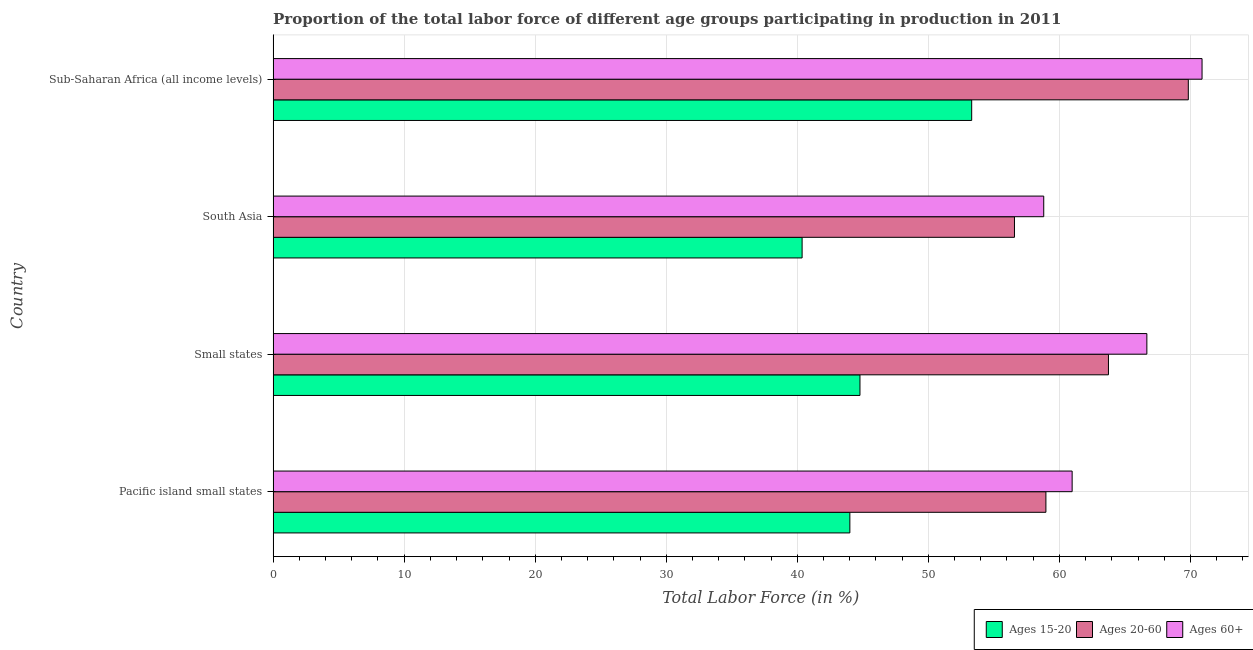Are the number of bars on each tick of the Y-axis equal?
Give a very brief answer. Yes. How many bars are there on the 3rd tick from the top?
Ensure brevity in your answer.  3. How many bars are there on the 4th tick from the bottom?
Offer a very short reply. 3. What is the label of the 3rd group of bars from the top?
Offer a very short reply. Small states. What is the percentage of labor force within the age group 20-60 in Sub-Saharan Africa (all income levels)?
Offer a very short reply. 69.84. Across all countries, what is the maximum percentage of labor force above age 60?
Your response must be concise. 70.89. Across all countries, what is the minimum percentage of labor force within the age group 15-20?
Your answer should be very brief. 40.37. In which country was the percentage of labor force above age 60 maximum?
Ensure brevity in your answer.  Sub-Saharan Africa (all income levels). In which country was the percentage of labor force within the age group 15-20 minimum?
Give a very brief answer. South Asia. What is the total percentage of labor force within the age group 20-60 in the graph?
Your response must be concise. 249.13. What is the difference between the percentage of labor force within the age group 20-60 in Small states and that in Sub-Saharan Africa (all income levels)?
Your answer should be very brief. -6.09. What is the difference between the percentage of labor force within the age group 20-60 in South Asia and the percentage of labor force within the age group 15-20 in Sub-Saharan Africa (all income levels)?
Give a very brief answer. 3.27. What is the average percentage of labor force above age 60 per country?
Give a very brief answer. 64.34. What is the difference between the percentage of labor force within the age group 20-60 and percentage of labor force above age 60 in Small states?
Give a very brief answer. -2.93. What is the ratio of the percentage of labor force within the age group 20-60 in Pacific island small states to that in Small states?
Provide a short and direct response. 0.93. What is the difference between the highest and the second highest percentage of labor force within the age group 15-20?
Give a very brief answer. 8.53. What is the difference between the highest and the lowest percentage of labor force above age 60?
Provide a succinct answer. 12.08. What does the 2nd bar from the top in Small states represents?
Your response must be concise. Ages 20-60. What does the 1st bar from the bottom in Pacific island small states represents?
Your answer should be very brief. Ages 15-20. Are all the bars in the graph horizontal?
Offer a very short reply. Yes. What is the difference between two consecutive major ticks on the X-axis?
Provide a short and direct response. 10. Are the values on the major ticks of X-axis written in scientific E-notation?
Keep it short and to the point. No. Does the graph contain any zero values?
Keep it short and to the point. No. Does the graph contain grids?
Your answer should be compact. Yes. What is the title of the graph?
Provide a succinct answer. Proportion of the total labor force of different age groups participating in production in 2011. Does "Ages 15-20" appear as one of the legend labels in the graph?
Offer a terse response. Yes. What is the Total Labor Force (in %) of Ages 15-20 in Pacific island small states?
Give a very brief answer. 44.01. What is the Total Labor Force (in %) of Ages 20-60 in Pacific island small states?
Offer a very short reply. 58.97. What is the Total Labor Force (in %) in Ages 60+ in Pacific island small states?
Offer a very short reply. 60.97. What is the Total Labor Force (in %) in Ages 15-20 in Small states?
Provide a succinct answer. 44.78. What is the Total Labor Force (in %) of Ages 20-60 in Small states?
Give a very brief answer. 63.75. What is the Total Labor Force (in %) of Ages 60+ in Small states?
Make the answer very short. 66.68. What is the Total Labor Force (in %) of Ages 15-20 in South Asia?
Make the answer very short. 40.37. What is the Total Labor Force (in %) in Ages 20-60 in South Asia?
Your answer should be very brief. 56.57. What is the Total Labor Force (in %) of Ages 60+ in South Asia?
Your response must be concise. 58.81. What is the Total Labor Force (in %) of Ages 15-20 in Sub-Saharan Africa (all income levels)?
Your answer should be compact. 53.31. What is the Total Labor Force (in %) of Ages 20-60 in Sub-Saharan Africa (all income levels)?
Offer a terse response. 69.84. What is the Total Labor Force (in %) in Ages 60+ in Sub-Saharan Africa (all income levels)?
Offer a very short reply. 70.89. Across all countries, what is the maximum Total Labor Force (in %) in Ages 15-20?
Keep it short and to the point. 53.31. Across all countries, what is the maximum Total Labor Force (in %) in Ages 20-60?
Make the answer very short. 69.84. Across all countries, what is the maximum Total Labor Force (in %) in Ages 60+?
Ensure brevity in your answer.  70.89. Across all countries, what is the minimum Total Labor Force (in %) in Ages 15-20?
Your answer should be very brief. 40.37. Across all countries, what is the minimum Total Labor Force (in %) of Ages 20-60?
Offer a terse response. 56.57. Across all countries, what is the minimum Total Labor Force (in %) of Ages 60+?
Provide a short and direct response. 58.81. What is the total Total Labor Force (in %) of Ages 15-20 in the graph?
Make the answer very short. 182.47. What is the total Total Labor Force (in %) in Ages 20-60 in the graph?
Give a very brief answer. 249.13. What is the total Total Labor Force (in %) of Ages 60+ in the graph?
Offer a terse response. 257.35. What is the difference between the Total Labor Force (in %) in Ages 15-20 in Pacific island small states and that in Small states?
Offer a very short reply. -0.77. What is the difference between the Total Labor Force (in %) of Ages 20-60 in Pacific island small states and that in Small states?
Keep it short and to the point. -4.77. What is the difference between the Total Labor Force (in %) of Ages 60+ in Pacific island small states and that in Small states?
Make the answer very short. -5.7. What is the difference between the Total Labor Force (in %) of Ages 15-20 in Pacific island small states and that in South Asia?
Ensure brevity in your answer.  3.64. What is the difference between the Total Labor Force (in %) of Ages 20-60 in Pacific island small states and that in South Asia?
Your answer should be very brief. 2.4. What is the difference between the Total Labor Force (in %) in Ages 60+ in Pacific island small states and that in South Asia?
Provide a succinct answer. 2.17. What is the difference between the Total Labor Force (in %) in Ages 15-20 in Pacific island small states and that in Sub-Saharan Africa (all income levels)?
Keep it short and to the point. -9.3. What is the difference between the Total Labor Force (in %) in Ages 20-60 in Pacific island small states and that in Sub-Saharan Africa (all income levels)?
Your response must be concise. -10.87. What is the difference between the Total Labor Force (in %) in Ages 60+ in Pacific island small states and that in Sub-Saharan Africa (all income levels)?
Make the answer very short. -9.91. What is the difference between the Total Labor Force (in %) in Ages 15-20 in Small states and that in South Asia?
Offer a terse response. 4.41. What is the difference between the Total Labor Force (in %) in Ages 20-60 in Small states and that in South Asia?
Your answer should be compact. 7.17. What is the difference between the Total Labor Force (in %) of Ages 60+ in Small states and that in South Asia?
Make the answer very short. 7.87. What is the difference between the Total Labor Force (in %) in Ages 15-20 in Small states and that in Sub-Saharan Africa (all income levels)?
Keep it short and to the point. -8.53. What is the difference between the Total Labor Force (in %) of Ages 20-60 in Small states and that in Sub-Saharan Africa (all income levels)?
Keep it short and to the point. -6.09. What is the difference between the Total Labor Force (in %) of Ages 60+ in Small states and that in Sub-Saharan Africa (all income levels)?
Provide a short and direct response. -4.21. What is the difference between the Total Labor Force (in %) in Ages 15-20 in South Asia and that in Sub-Saharan Africa (all income levels)?
Keep it short and to the point. -12.94. What is the difference between the Total Labor Force (in %) in Ages 20-60 in South Asia and that in Sub-Saharan Africa (all income levels)?
Your response must be concise. -13.27. What is the difference between the Total Labor Force (in %) in Ages 60+ in South Asia and that in Sub-Saharan Africa (all income levels)?
Provide a succinct answer. -12.08. What is the difference between the Total Labor Force (in %) in Ages 15-20 in Pacific island small states and the Total Labor Force (in %) in Ages 20-60 in Small states?
Keep it short and to the point. -19.73. What is the difference between the Total Labor Force (in %) of Ages 15-20 in Pacific island small states and the Total Labor Force (in %) of Ages 60+ in Small states?
Your answer should be very brief. -22.66. What is the difference between the Total Labor Force (in %) in Ages 20-60 in Pacific island small states and the Total Labor Force (in %) in Ages 60+ in Small states?
Your answer should be very brief. -7.7. What is the difference between the Total Labor Force (in %) of Ages 15-20 in Pacific island small states and the Total Labor Force (in %) of Ages 20-60 in South Asia?
Keep it short and to the point. -12.56. What is the difference between the Total Labor Force (in %) in Ages 15-20 in Pacific island small states and the Total Labor Force (in %) in Ages 60+ in South Asia?
Provide a short and direct response. -14.79. What is the difference between the Total Labor Force (in %) in Ages 20-60 in Pacific island small states and the Total Labor Force (in %) in Ages 60+ in South Asia?
Your response must be concise. 0.17. What is the difference between the Total Labor Force (in %) in Ages 15-20 in Pacific island small states and the Total Labor Force (in %) in Ages 20-60 in Sub-Saharan Africa (all income levels)?
Make the answer very short. -25.83. What is the difference between the Total Labor Force (in %) in Ages 15-20 in Pacific island small states and the Total Labor Force (in %) in Ages 60+ in Sub-Saharan Africa (all income levels)?
Your answer should be compact. -26.88. What is the difference between the Total Labor Force (in %) of Ages 20-60 in Pacific island small states and the Total Labor Force (in %) of Ages 60+ in Sub-Saharan Africa (all income levels)?
Give a very brief answer. -11.91. What is the difference between the Total Labor Force (in %) of Ages 15-20 in Small states and the Total Labor Force (in %) of Ages 20-60 in South Asia?
Ensure brevity in your answer.  -11.79. What is the difference between the Total Labor Force (in %) of Ages 15-20 in Small states and the Total Labor Force (in %) of Ages 60+ in South Asia?
Your answer should be compact. -14.02. What is the difference between the Total Labor Force (in %) of Ages 20-60 in Small states and the Total Labor Force (in %) of Ages 60+ in South Asia?
Your answer should be very brief. 4.94. What is the difference between the Total Labor Force (in %) of Ages 15-20 in Small states and the Total Labor Force (in %) of Ages 20-60 in Sub-Saharan Africa (all income levels)?
Make the answer very short. -25.06. What is the difference between the Total Labor Force (in %) in Ages 15-20 in Small states and the Total Labor Force (in %) in Ages 60+ in Sub-Saharan Africa (all income levels)?
Give a very brief answer. -26.11. What is the difference between the Total Labor Force (in %) in Ages 20-60 in Small states and the Total Labor Force (in %) in Ages 60+ in Sub-Saharan Africa (all income levels)?
Make the answer very short. -7.14. What is the difference between the Total Labor Force (in %) in Ages 15-20 in South Asia and the Total Labor Force (in %) in Ages 20-60 in Sub-Saharan Africa (all income levels)?
Your answer should be compact. -29.47. What is the difference between the Total Labor Force (in %) in Ages 15-20 in South Asia and the Total Labor Force (in %) in Ages 60+ in Sub-Saharan Africa (all income levels)?
Offer a terse response. -30.52. What is the difference between the Total Labor Force (in %) in Ages 20-60 in South Asia and the Total Labor Force (in %) in Ages 60+ in Sub-Saharan Africa (all income levels)?
Your answer should be very brief. -14.31. What is the average Total Labor Force (in %) of Ages 15-20 per country?
Give a very brief answer. 45.62. What is the average Total Labor Force (in %) in Ages 20-60 per country?
Provide a short and direct response. 62.28. What is the average Total Labor Force (in %) of Ages 60+ per country?
Keep it short and to the point. 64.34. What is the difference between the Total Labor Force (in %) in Ages 15-20 and Total Labor Force (in %) in Ages 20-60 in Pacific island small states?
Keep it short and to the point. -14.96. What is the difference between the Total Labor Force (in %) in Ages 15-20 and Total Labor Force (in %) in Ages 60+ in Pacific island small states?
Your answer should be very brief. -16.96. What is the difference between the Total Labor Force (in %) of Ages 20-60 and Total Labor Force (in %) of Ages 60+ in Pacific island small states?
Your response must be concise. -2. What is the difference between the Total Labor Force (in %) in Ages 15-20 and Total Labor Force (in %) in Ages 20-60 in Small states?
Ensure brevity in your answer.  -18.96. What is the difference between the Total Labor Force (in %) in Ages 15-20 and Total Labor Force (in %) in Ages 60+ in Small states?
Offer a very short reply. -21.89. What is the difference between the Total Labor Force (in %) of Ages 20-60 and Total Labor Force (in %) of Ages 60+ in Small states?
Provide a succinct answer. -2.93. What is the difference between the Total Labor Force (in %) of Ages 15-20 and Total Labor Force (in %) of Ages 20-60 in South Asia?
Your answer should be very brief. -16.21. What is the difference between the Total Labor Force (in %) of Ages 15-20 and Total Labor Force (in %) of Ages 60+ in South Asia?
Keep it short and to the point. -18.44. What is the difference between the Total Labor Force (in %) in Ages 20-60 and Total Labor Force (in %) in Ages 60+ in South Asia?
Offer a very short reply. -2.23. What is the difference between the Total Labor Force (in %) of Ages 15-20 and Total Labor Force (in %) of Ages 20-60 in Sub-Saharan Africa (all income levels)?
Ensure brevity in your answer.  -16.53. What is the difference between the Total Labor Force (in %) in Ages 15-20 and Total Labor Force (in %) in Ages 60+ in Sub-Saharan Africa (all income levels)?
Give a very brief answer. -17.58. What is the difference between the Total Labor Force (in %) in Ages 20-60 and Total Labor Force (in %) in Ages 60+ in Sub-Saharan Africa (all income levels)?
Offer a terse response. -1.05. What is the ratio of the Total Labor Force (in %) of Ages 15-20 in Pacific island small states to that in Small states?
Your answer should be very brief. 0.98. What is the ratio of the Total Labor Force (in %) of Ages 20-60 in Pacific island small states to that in Small states?
Your answer should be compact. 0.93. What is the ratio of the Total Labor Force (in %) of Ages 60+ in Pacific island small states to that in Small states?
Provide a succinct answer. 0.91. What is the ratio of the Total Labor Force (in %) in Ages 15-20 in Pacific island small states to that in South Asia?
Make the answer very short. 1.09. What is the ratio of the Total Labor Force (in %) of Ages 20-60 in Pacific island small states to that in South Asia?
Offer a very short reply. 1.04. What is the ratio of the Total Labor Force (in %) of Ages 60+ in Pacific island small states to that in South Asia?
Give a very brief answer. 1.04. What is the ratio of the Total Labor Force (in %) in Ages 15-20 in Pacific island small states to that in Sub-Saharan Africa (all income levels)?
Offer a very short reply. 0.83. What is the ratio of the Total Labor Force (in %) in Ages 20-60 in Pacific island small states to that in Sub-Saharan Africa (all income levels)?
Provide a short and direct response. 0.84. What is the ratio of the Total Labor Force (in %) in Ages 60+ in Pacific island small states to that in Sub-Saharan Africa (all income levels)?
Give a very brief answer. 0.86. What is the ratio of the Total Labor Force (in %) in Ages 15-20 in Small states to that in South Asia?
Provide a succinct answer. 1.11. What is the ratio of the Total Labor Force (in %) of Ages 20-60 in Small states to that in South Asia?
Offer a terse response. 1.13. What is the ratio of the Total Labor Force (in %) in Ages 60+ in Small states to that in South Asia?
Your answer should be compact. 1.13. What is the ratio of the Total Labor Force (in %) in Ages 15-20 in Small states to that in Sub-Saharan Africa (all income levels)?
Provide a short and direct response. 0.84. What is the ratio of the Total Labor Force (in %) in Ages 20-60 in Small states to that in Sub-Saharan Africa (all income levels)?
Give a very brief answer. 0.91. What is the ratio of the Total Labor Force (in %) of Ages 60+ in Small states to that in Sub-Saharan Africa (all income levels)?
Provide a succinct answer. 0.94. What is the ratio of the Total Labor Force (in %) in Ages 15-20 in South Asia to that in Sub-Saharan Africa (all income levels)?
Make the answer very short. 0.76. What is the ratio of the Total Labor Force (in %) in Ages 20-60 in South Asia to that in Sub-Saharan Africa (all income levels)?
Your answer should be very brief. 0.81. What is the ratio of the Total Labor Force (in %) of Ages 60+ in South Asia to that in Sub-Saharan Africa (all income levels)?
Your response must be concise. 0.83. What is the difference between the highest and the second highest Total Labor Force (in %) of Ages 15-20?
Your answer should be compact. 8.53. What is the difference between the highest and the second highest Total Labor Force (in %) in Ages 20-60?
Your answer should be compact. 6.09. What is the difference between the highest and the second highest Total Labor Force (in %) of Ages 60+?
Keep it short and to the point. 4.21. What is the difference between the highest and the lowest Total Labor Force (in %) of Ages 15-20?
Your answer should be very brief. 12.94. What is the difference between the highest and the lowest Total Labor Force (in %) of Ages 20-60?
Provide a short and direct response. 13.27. What is the difference between the highest and the lowest Total Labor Force (in %) of Ages 60+?
Ensure brevity in your answer.  12.08. 